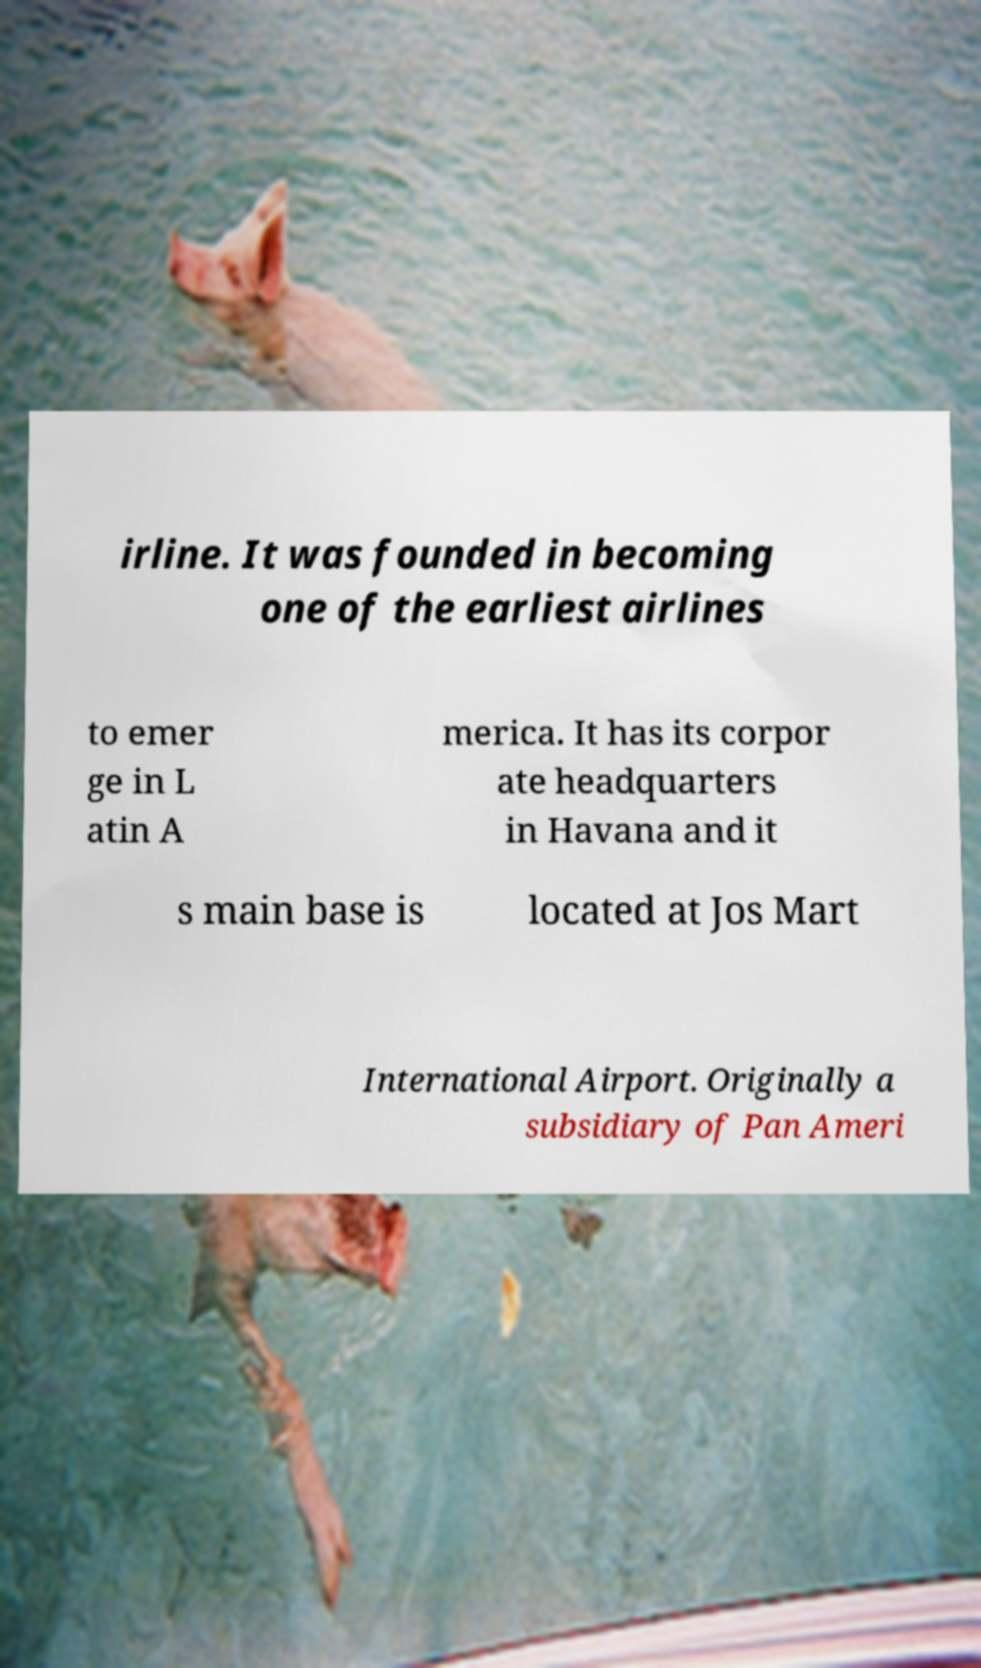Can you accurately transcribe the text from the provided image for me? irline. It was founded in becoming one of the earliest airlines to emer ge in L atin A merica. It has its corpor ate headquarters in Havana and it s main base is located at Jos Mart International Airport. Originally a subsidiary of Pan Ameri 